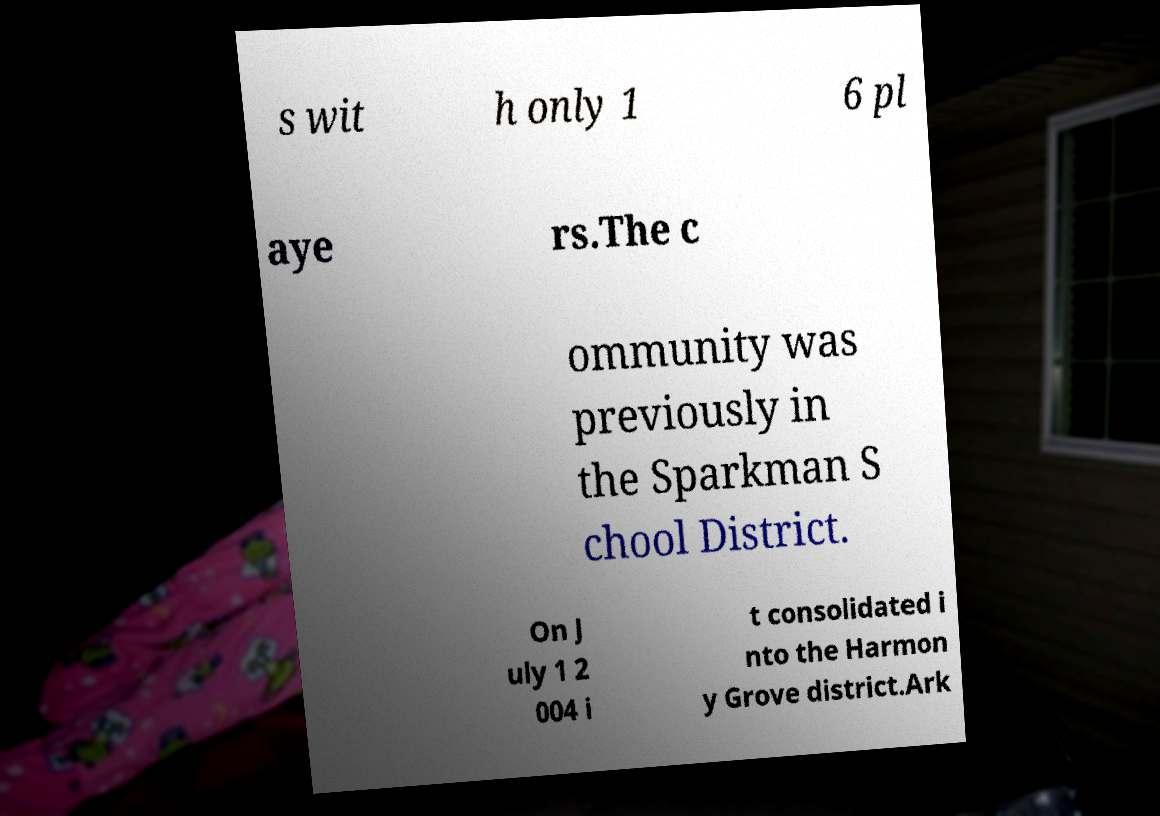Can you accurately transcribe the text from the provided image for me? s wit h only 1 6 pl aye rs.The c ommunity was previously in the Sparkman S chool District. On J uly 1 2 004 i t consolidated i nto the Harmon y Grove district.Ark 